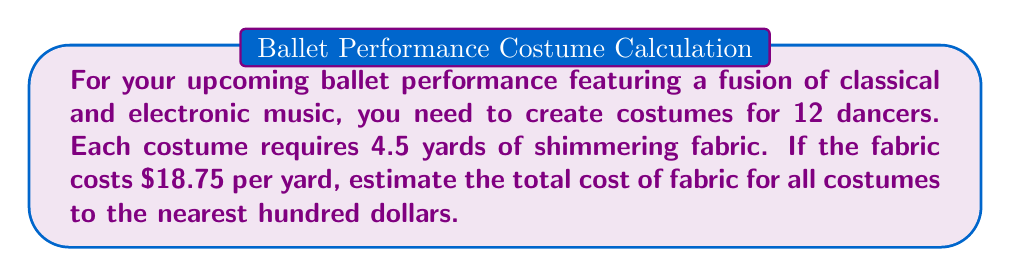Give your solution to this math problem. Let's break this down step-by-step:

1. Calculate the total yards of fabric needed:
   $$ \text{Total yards} = \text{Number of dancers} \times \text{Yards per costume} $$
   $$ \text{Total yards} = 12 \times 4.5 = 54 \text{ yards} $$

2. Calculate the exact cost of fabric:
   $$ \text{Exact cost} = \text{Total yards} \times \text{Cost per yard} $$
   $$ \text{Exact cost} = 54 \times \$18.75 = \$1,012.50 $$

3. Round the cost to the nearest hundred dollars:
   $\$1,012.50$ is closer to $\$1,000$ than to $\$1,100$

Therefore, the estimated cost of fabric for all costumes, rounded to the nearest hundred dollars, is $\$1,000$.
Answer: $\$1,000$ 